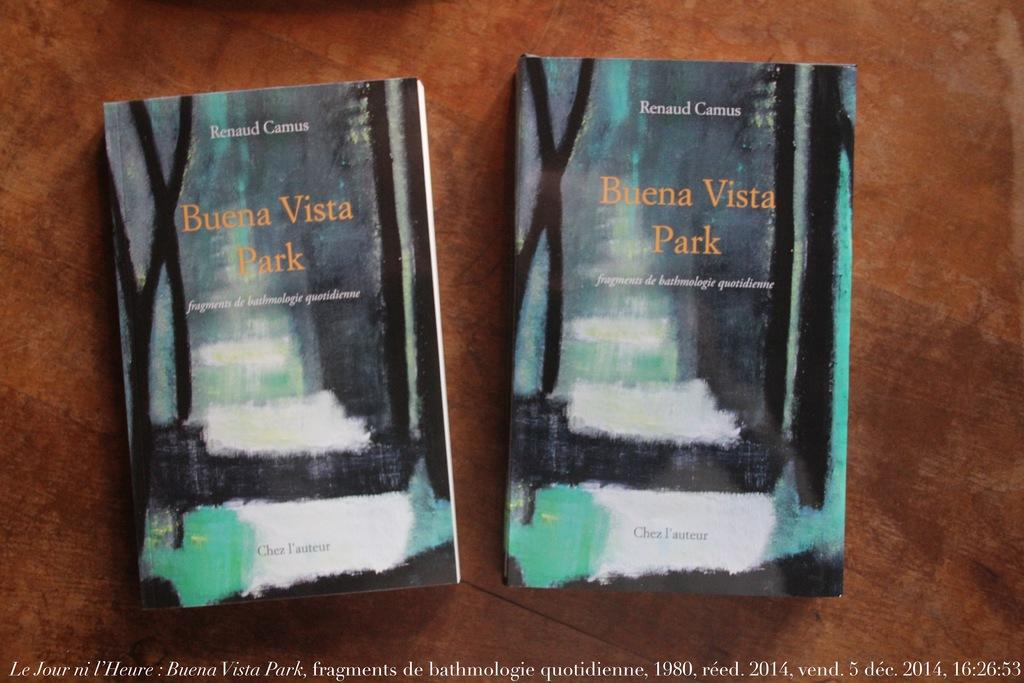<image>
Offer a succinct explanation of the picture presented. Book cover for Buena Vista Park showing some black and white on the cover. 